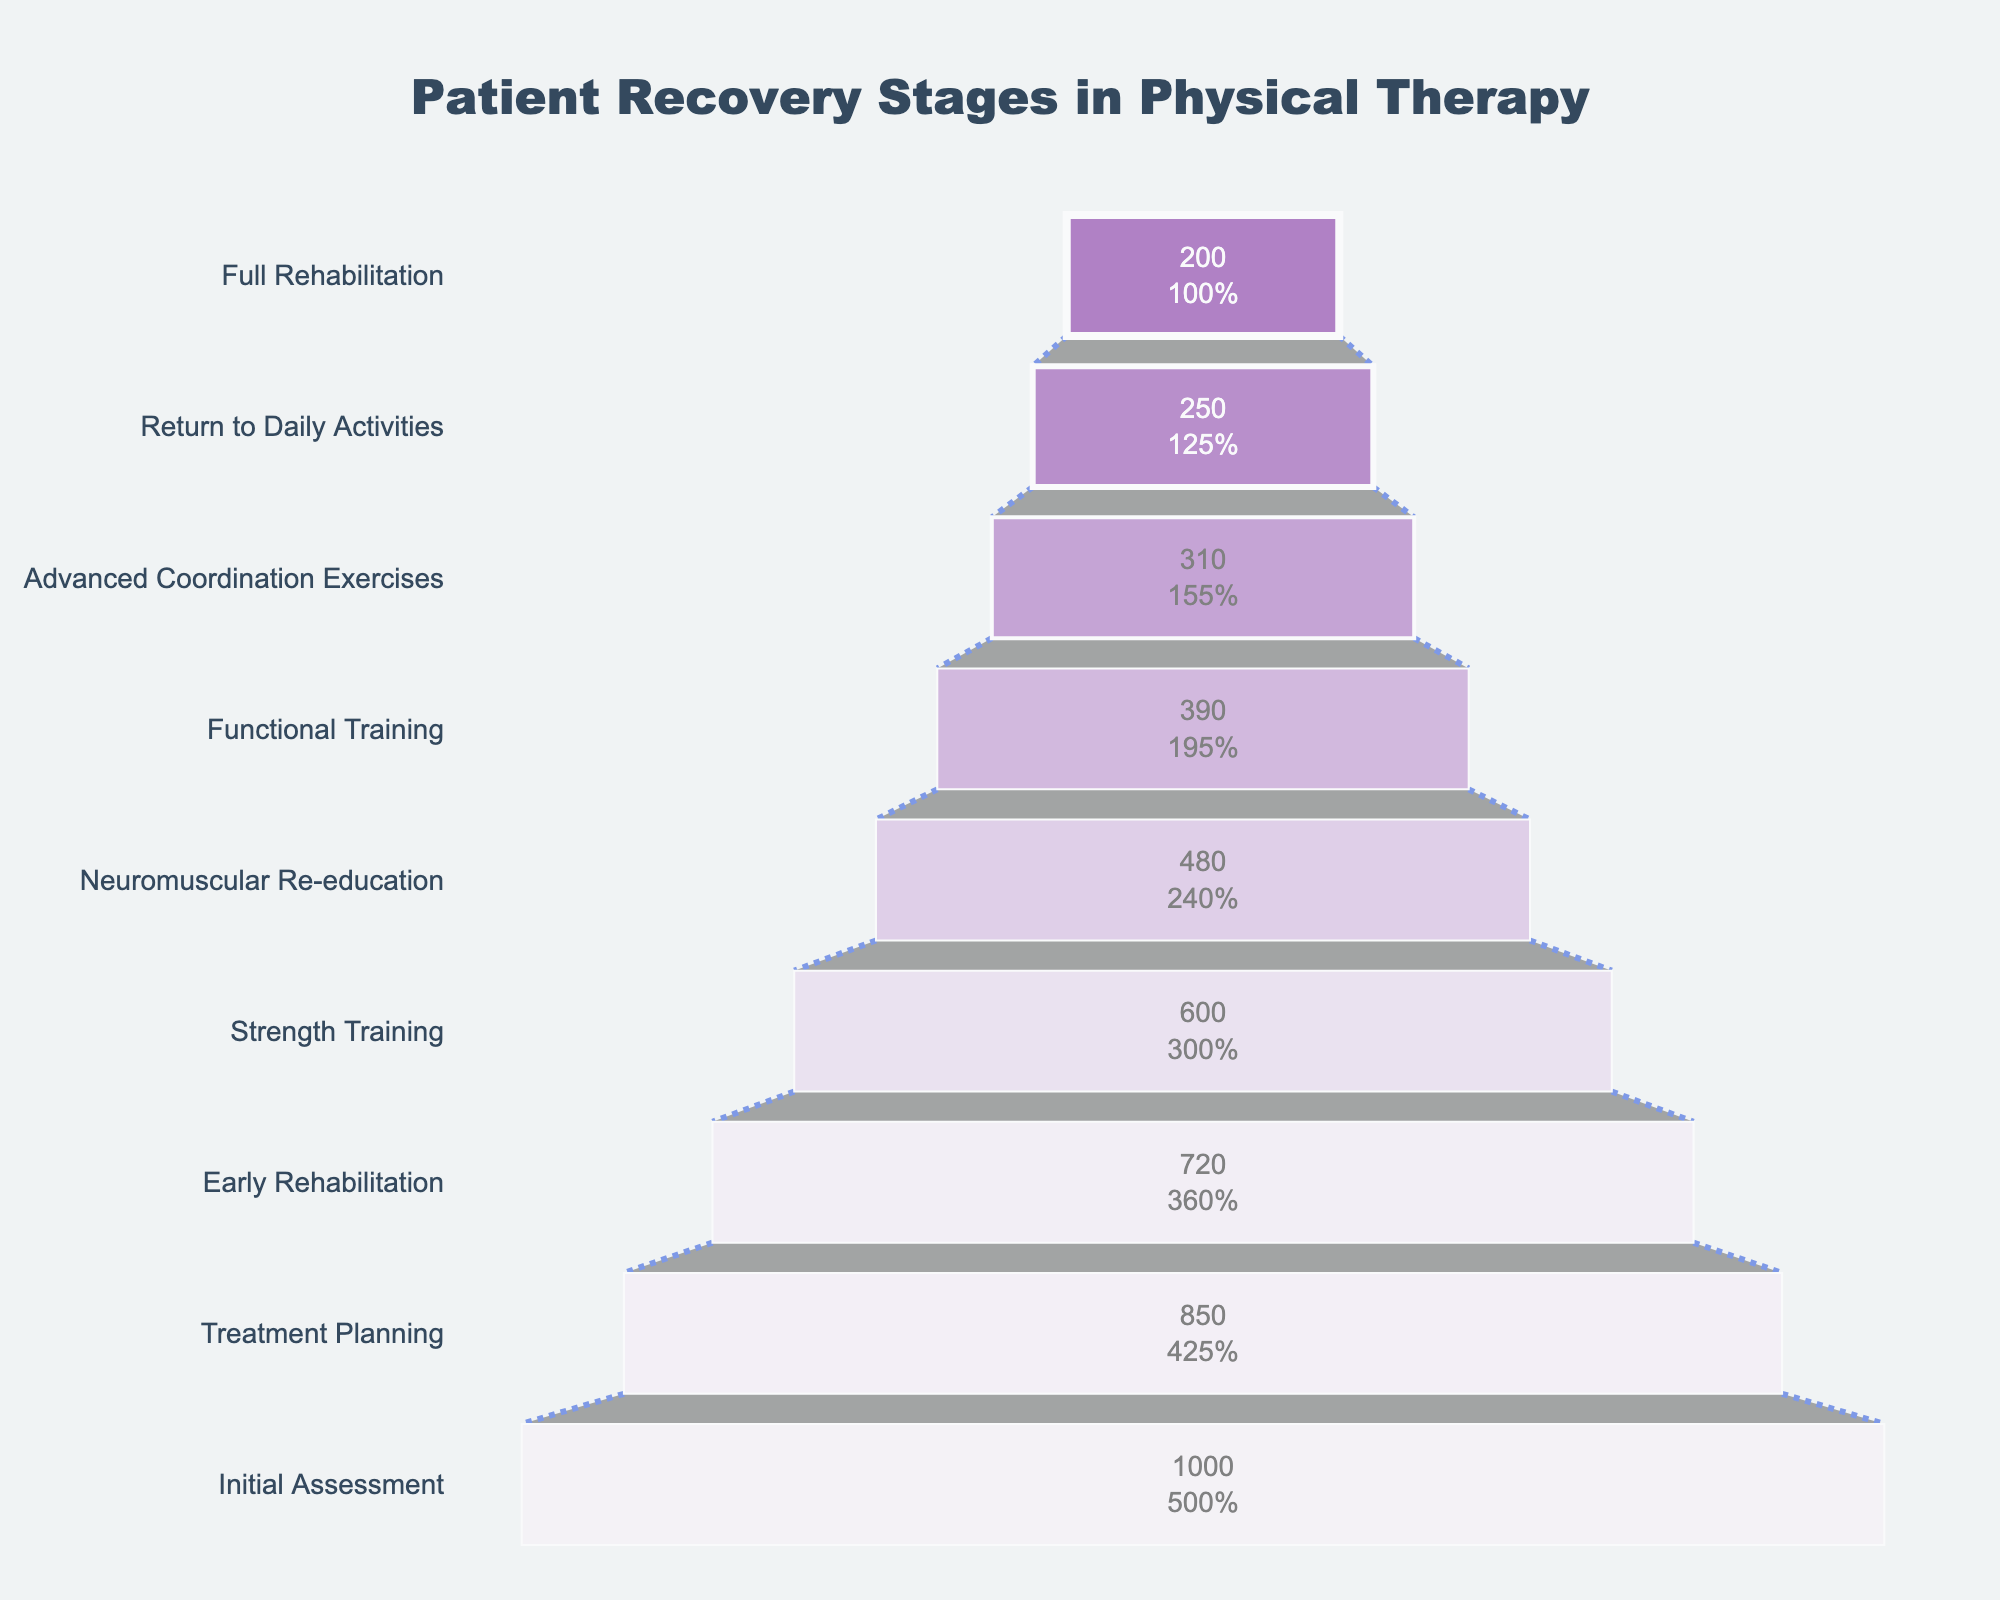How many stages are there in the patient recovery process? The funnel chart lists the stages of the recovery process. Count the number of distinct stages.
Answer: 9 From which stage to which stage does the largest drop in patient numbers occur? Observe the patient numbers at each stage and identify the largest decrease between two consecutive stages.
Answer: Strength Training to Neuromuscular Re-education What is the percentage of patients that reach full rehabilitation relative to the initial assessment group? Divide the number of patients in the Full Rehabilitation stage by the number of patients in the Initial Assessment stage, then multiply by 100 to get the percentage.
Answer: 20% By how many patients does the number decrease from Early Rehabilitation to Strength Training? Subtract the number of patients in Strength Training from the number of patients in Early Rehabilitation.
Answer: 120 Which stage has less than half the number of patients as the Initial Assessment? Determine the stages where the number of patients is less than half of 1000 (which is 500).
Answer: Functional Training, Advanced Coordination Exercises, Return to Daily Activities, Full Rehabilitation Between Treatment Planning and Neuromuscular Re-education, what is the combined percentage drop in patients? Calculate the percentage decrease from Treatment Planning to Neuromuscular Re-education by summing the differences and dividing by the initial number, then multiplying by 100.
Answer: 43% Which stage follows Neuromuscular Re-education? Look at the stage listed immediately after Neuromuscular Re-education in the funnel chart.
Answer: Functional Training Do more patients drop out between Early Rehabilitation and Strength Training or between Advanced Coordination Exercises and Return to Daily Activities? Compare the patient number decreases between Early Rehabilitation to Strength Training, and Advanced Coordination Exercises to Return to Daily Activities.
Answer: Early Rehabilitation to Strength Training What is the total number of patients that reach the final three stages (Advanced Coordination Exercises, Return to Daily Activities, Full Rehabilitation)? Sum the number of patients in the stages Advanced Coordination Exercises, Return to Daily Activities, and Full Rehabilitation.
Answer: 760 How many patients advance from the Early Rehabilitation to at least Functional Training? Look at the number of patients in the respective stages to find those who make it to Functional Training and beyond starting from Early Rehabilitation.
Answer: 390 